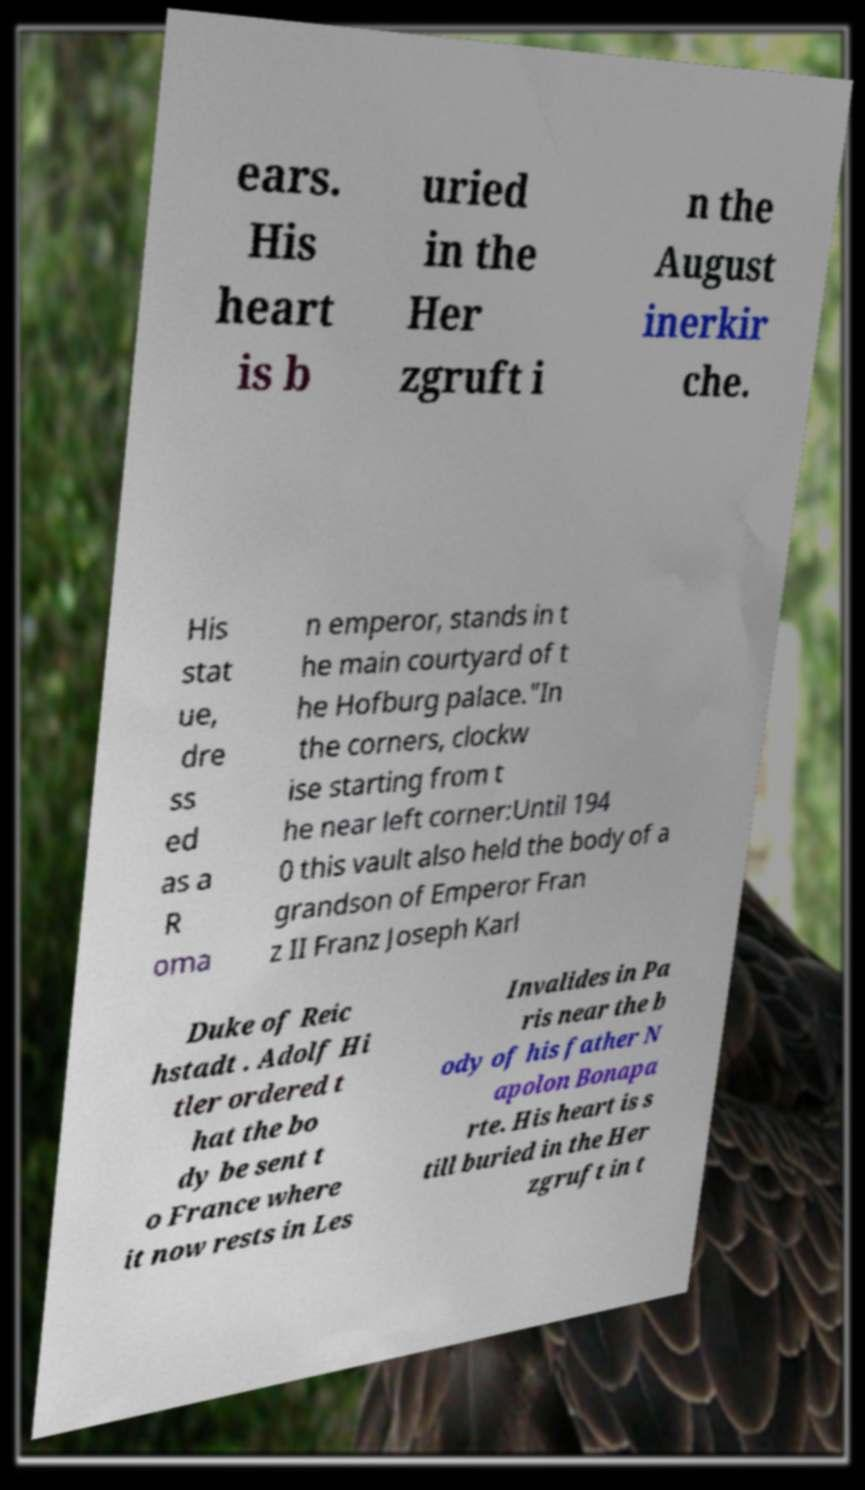Please identify and transcribe the text found in this image. ears. His heart is b uried in the Her zgruft i n the August inerkir che. His stat ue, dre ss ed as a R oma n emperor, stands in t he main courtyard of t he Hofburg palace."In the corners, clockw ise starting from t he near left corner:Until 194 0 this vault also held the body of a grandson of Emperor Fran z II Franz Joseph Karl Duke of Reic hstadt . Adolf Hi tler ordered t hat the bo dy be sent t o France where it now rests in Les Invalides in Pa ris near the b ody of his father N apolon Bonapa rte. His heart is s till buried in the Her zgruft in t 